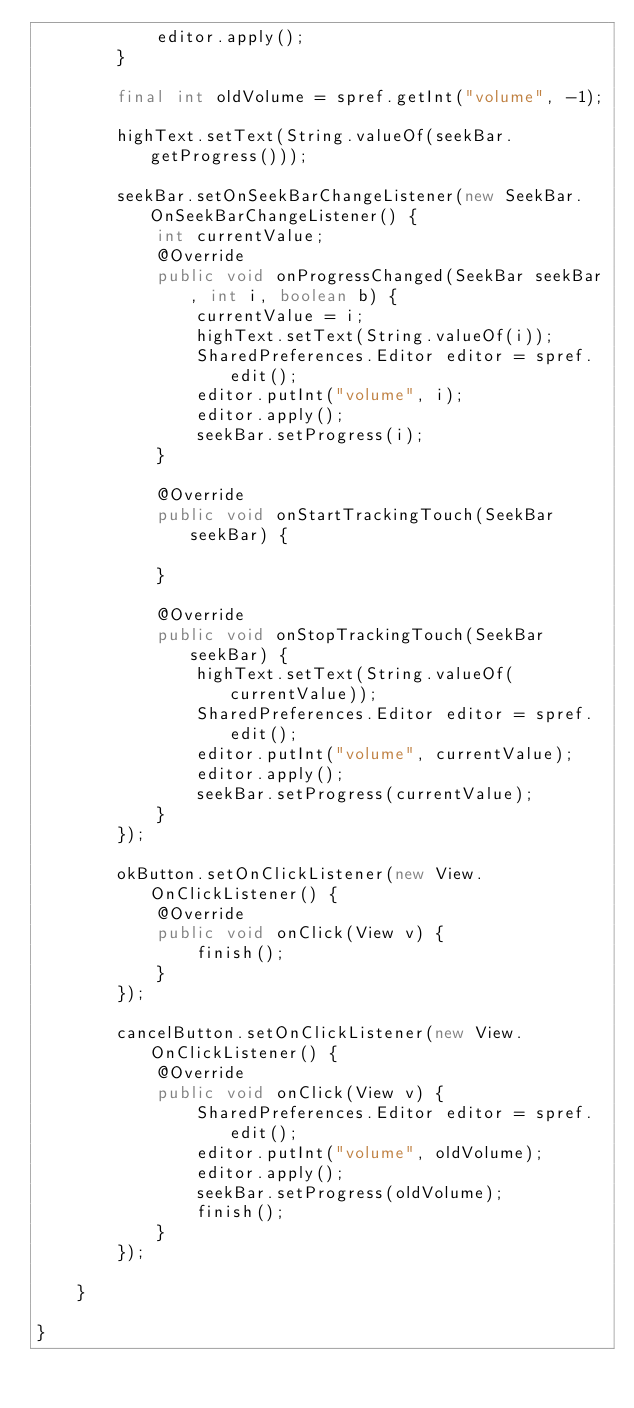<code> <loc_0><loc_0><loc_500><loc_500><_Java_>            editor.apply();
        }

        final int oldVolume = spref.getInt("volume", -1);

        highText.setText(String.valueOf(seekBar.getProgress()));

        seekBar.setOnSeekBarChangeListener(new SeekBar.OnSeekBarChangeListener() {
            int currentValue;
            @Override
            public void onProgressChanged(SeekBar seekBar, int i, boolean b) {
                currentValue = i;
                highText.setText(String.valueOf(i));
                SharedPreferences.Editor editor = spref.edit();
                editor.putInt("volume", i);
                editor.apply();
                seekBar.setProgress(i);
            }

            @Override
            public void onStartTrackingTouch(SeekBar seekBar) {

            }

            @Override
            public void onStopTrackingTouch(SeekBar seekBar) {
                highText.setText(String.valueOf(currentValue));
                SharedPreferences.Editor editor = spref.edit();
                editor.putInt("volume", currentValue);
                editor.apply();
                seekBar.setProgress(currentValue);
            }
        });

        okButton.setOnClickListener(new View.OnClickListener() {
            @Override
            public void onClick(View v) {
                finish();
            }
        });

        cancelButton.setOnClickListener(new View.OnClickListener() {
            @Override
            public void onClick(View v) {
                SharedPreferences.Editor editor = spref.edit();
                editor.putInt("volume", oldVolume);
                editor.apply();
                seekBar.setProgress(oldVolume);
                finish();
            }
        });

    }

}</code> 